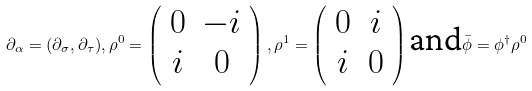<formula> <loc_0><loc_0><loc_500><loc_500>\partial _ { \alpha } = ( \partial _ { \sigma } , \partial _ { \tau } ) , \rho ^ { 0 } = \left ( \begin{array} { c c } 0 & - i \\ i & 0 \end{array} \right ) , \rho ^ { 1 } = \left ( \begin{array} { c c } 0 & i \\ i & 0 \end{array} \right ) { \text {and} } \bar { \phi } = \phi ^ { \dag } \rho ^ { 0 }</formula> 